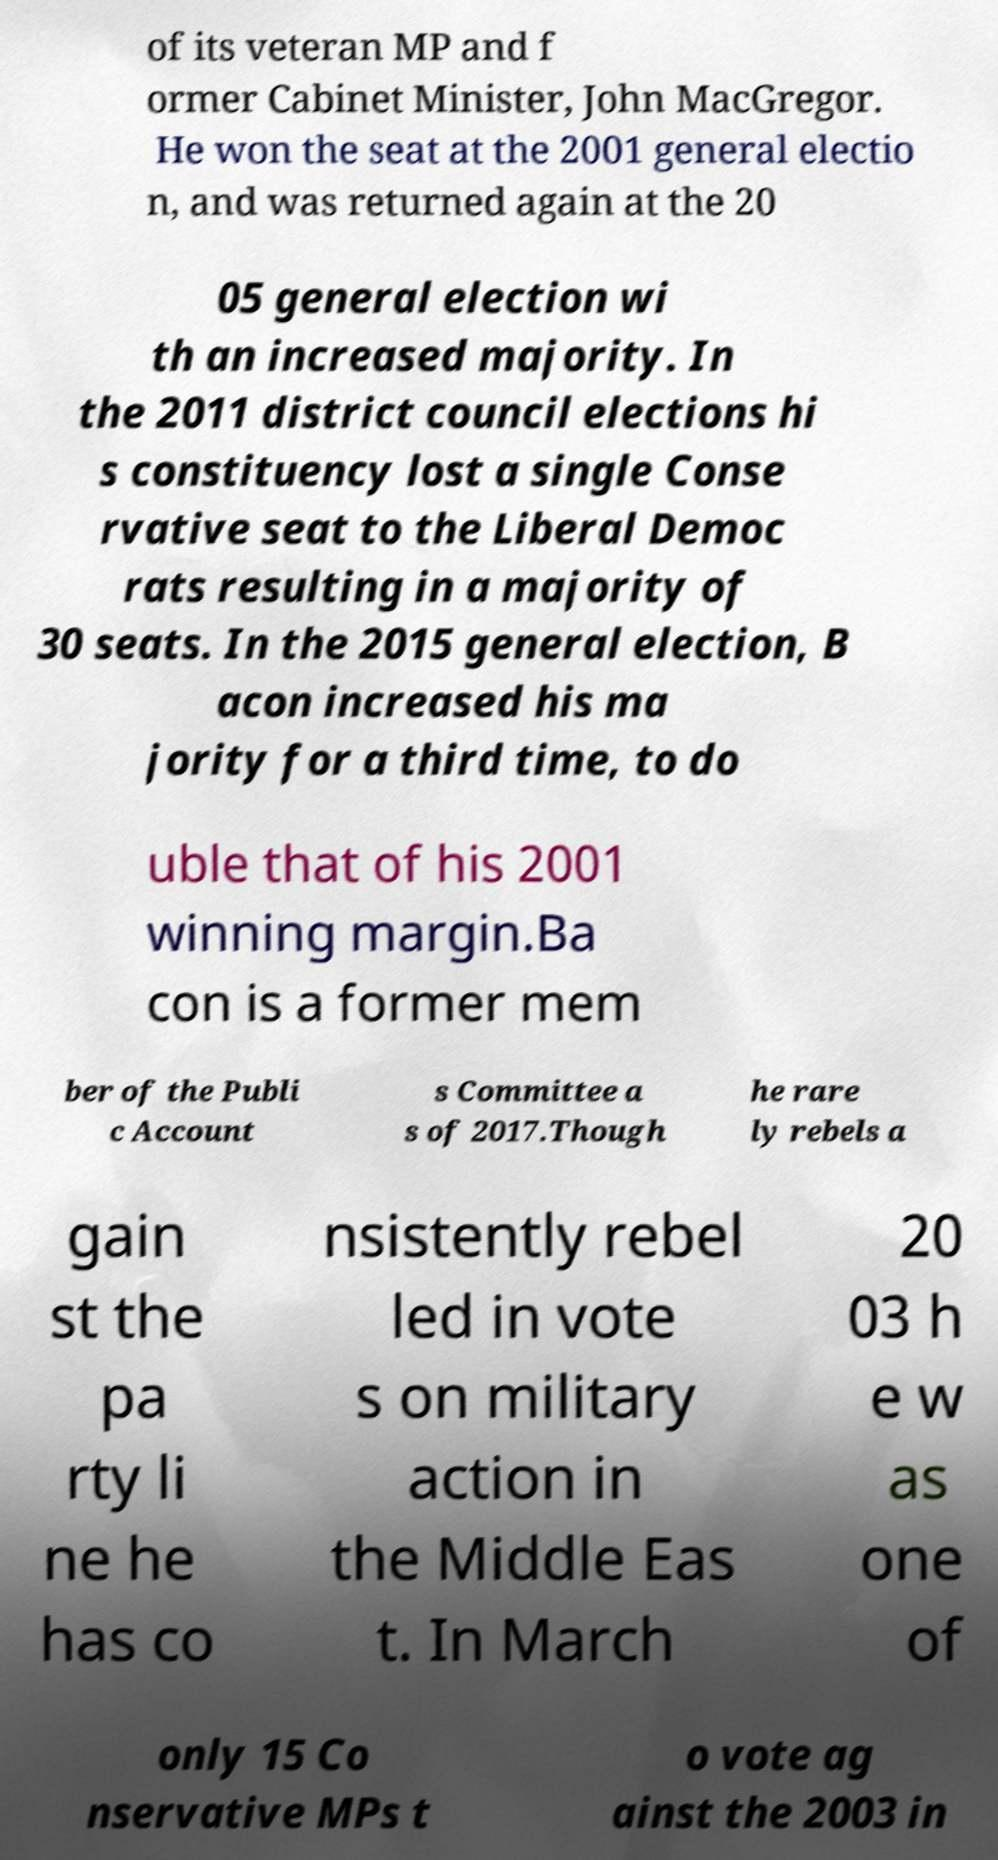I need the written content from this picture converted into text. Can you do that? of its veteran MP and f ormer Cabinet Minister, John MacGregor. He won the seat at the 2001 general electio n, and was returned again at the 20 05 general election wi th an increased majority. In the 2011 district council elections hi s constituency lost a single Conse rvative seat to the Liberal Democ rats resulting in a majority of 30 seats. In the 2015 general election, B acon increased his ma jority for a third time, to do uble that of his 2001 winning margin.Ba con is a former mem ber of the Publi c Account s Committee a s of 2017.Though he rare ly rebels a gain st the pa rty li ne he has co nsistently rebel led in vote s on military action in the Middle Eas t. In March 20 03 h e w as one of only 15 Co nservative MPs t o vote ag ainst the 2003 in 